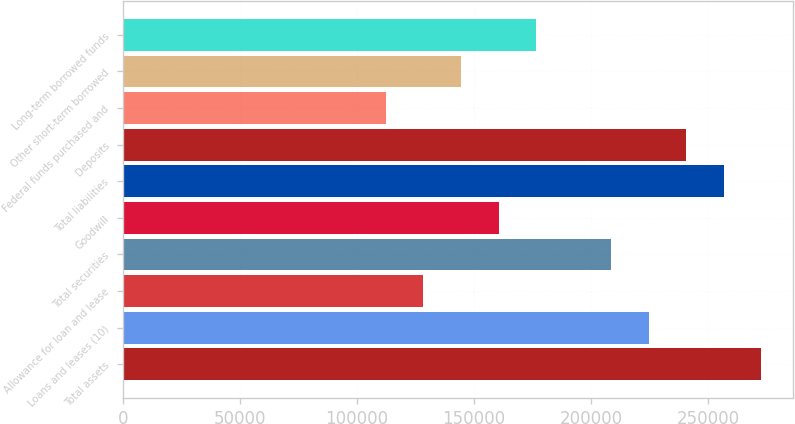Convert chart. <chart><loc_0><loc_0><loc_500><loc_500><bar_chart><fcel>Total assets<fcel>Loans and leases (10)<fcel>Allowance for loan and lease<fcel>Total securities<fcel>Goodwill<fcel>Total liabilities<fcel>Deposits<fcel>Federal funds purchased and<fcel>Other short-term borrowed<fcel>Long-term borrowed funds<nl><fcel>272880<fcel>224725<fcel>128415<fcel>208673<fcel>160518<fcel>256828<fcel>240777<fcel>112363<fcel>144466<fcel>176570<nl></chart> 